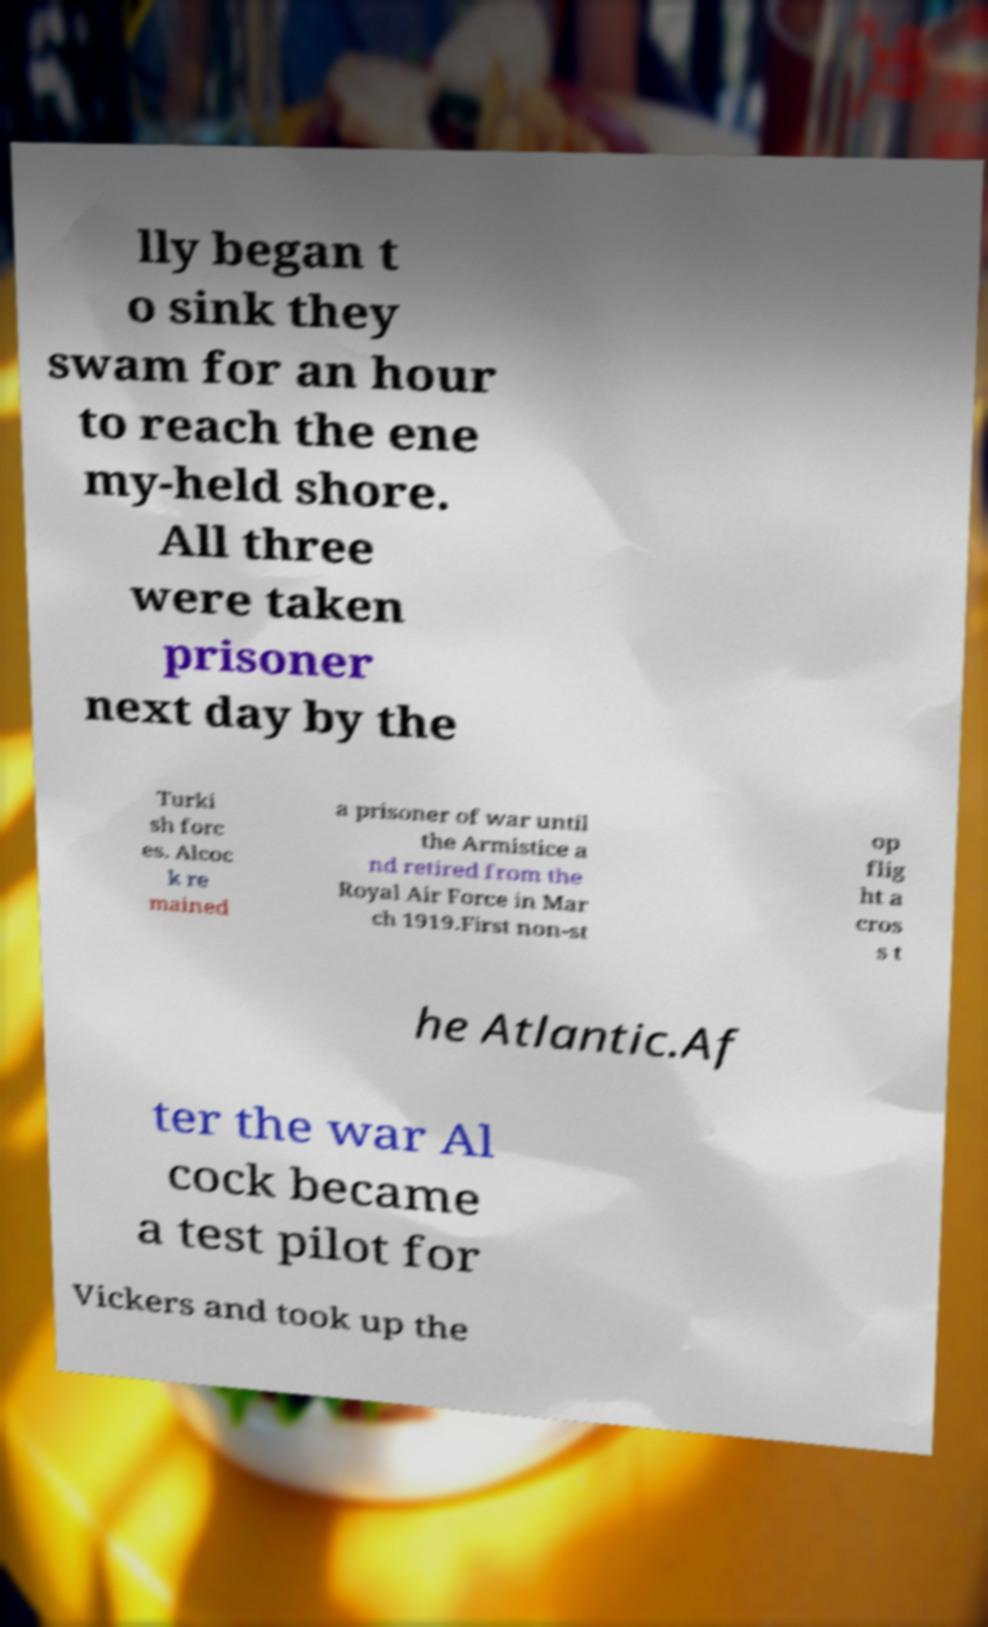Can you accurately transcribe the text from the provided image for me? lly began t o sink they swam for an hour to reach the ene my-held shore. All three were taken prisoner next day by the Turki sh forc es. Alcoc k re mained a prisoner of war until the Armistice a nd retired from the Royal Air Force in Mar ch 1919.First non-st op flig ht a cros s t he Atlantic.Af ter the war Al cock became a test pilot for Vickers and took up the 